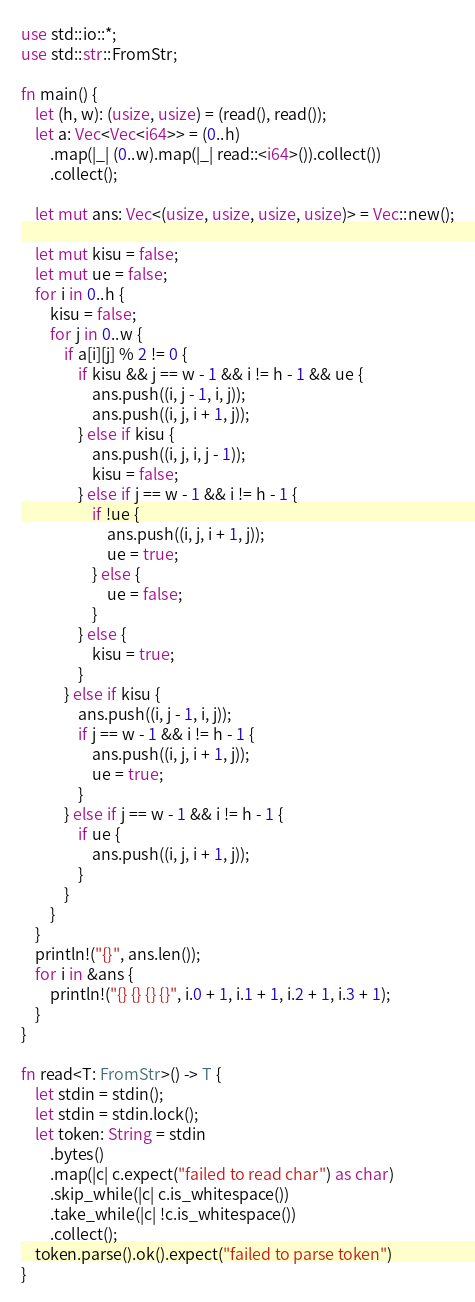<code> <loc_0><loc_0><loc_500><loc_500><_Rust_>use std::io::*;
use std::str::FromStr;

fn main() {
    let (h, w): (usize, usize) = (read(), read());
    let a: Vec<Vec<i64>> = (0..h)
        .map(|_| (0..w).map(|_| read::<i64>()).collect())
        .collect();

    let mut ans: Vec<(usize, usize, usize, usize)> = Vec::new();

    let mut kisu = false;
    let mut ue = false;
    for i in 0..h {
        kisu = false;
        for j in 0..w {
            if a[i][j] % 2 != 0 {
                if kisu && j == w - 1 && i != h - 1 && ue {
                    ans.push((i, j - 1, i, j));
                    ans.push((i, j, i + 1, j));
                } else if kisu {
                    ans.push((i, j, i, j - 1));
                    kisu = false;
                } else if j == w - 1 && i != h - 1 {
                    if !ue {
                        ans.push((i, j, i + 1, j));
                        ue = true;
                    } else {
                        ue = false;
                    }
                } else {
                    kisu = true;
                }
            } else if kisu {
                ans.push((i, j - 1, i, j));
                if j == w - 1 && i != h - 1 {
                    ans.push((i, j, i + 1, j));
                    ue = true;
                }
            } else if j == w - 1 && i != h - 1 {
                if ue {
                    ans.push((i, j, i + 1, j));
                }
            }
        }
    }
    println!("{}", ans.len());
    for i in &ans {
        println!("{} {} {} {}", i.0 + 1, i.1 + 1, i.2 + 1, i.3 + 1);
    }
}

fn read<T: FromStr>() -> T {
    let stdin = stdin();
    let stdin = stdin.lock();
    let token: String = stdin
        .bytes()
        .map(|c| c.expect("failed to read char") as char)
        .skip_while(|c| c.is_whitespace())
        .take_while(|c| !c.is_whitespace())
        .collect();
    token.parse().ok().expect("failed to parse token")
}
</code> 